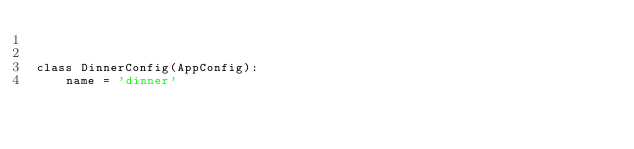Convert code to text. <code><loc_0><loc_0><loc_500><loc_500><_Python_>

class DinnerConfig(AppConfig):
    name = 'dinner'
</code> 